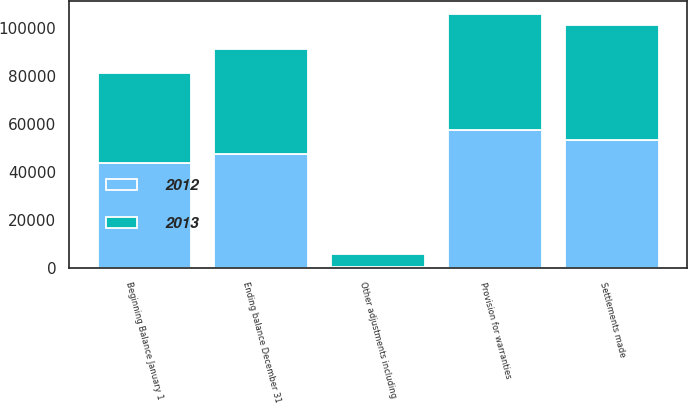Convert chart. <chart><loc_0><loc_0><loc_500><loc_500><stacked_bar_chart><ecel><fcel>Beginning Balance January 1<fcel>Provision for warranties<fcel>Settlements made<fcel>Other adjustments including<fcel>Ending balance December 31<nl><fcel>2012<fcel>43759<fcel>57458<fcel>53373<fcel>379<fcel>47465<nl><fcel>2013<fcel>37739<fcel>48626<fcel>48086<fcel>5480<fcel>43759<nl></chart> 